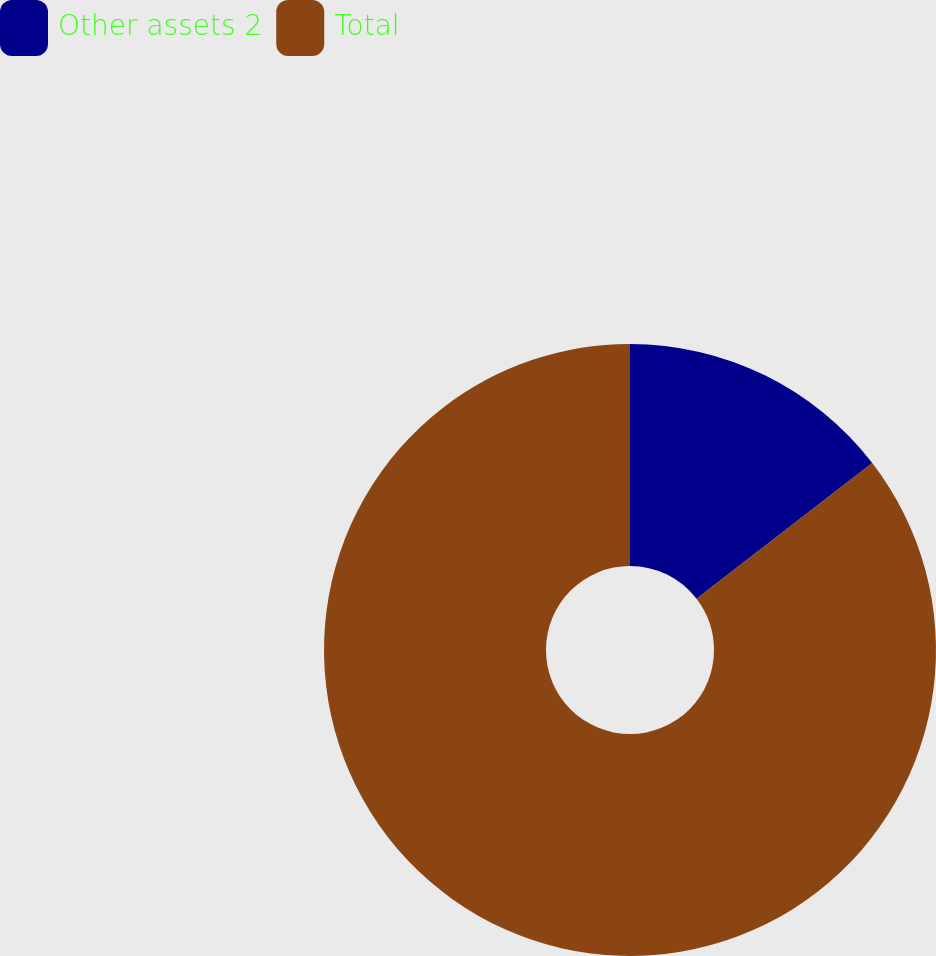Convert chart to OTSL. <chart><loc_0><loc_0><loc_500><loc_500><pie_chart><fcel>Other assets 2<fcel>Total<nl><fcel>14.54%<fcel>85.46%<nl></chart> 